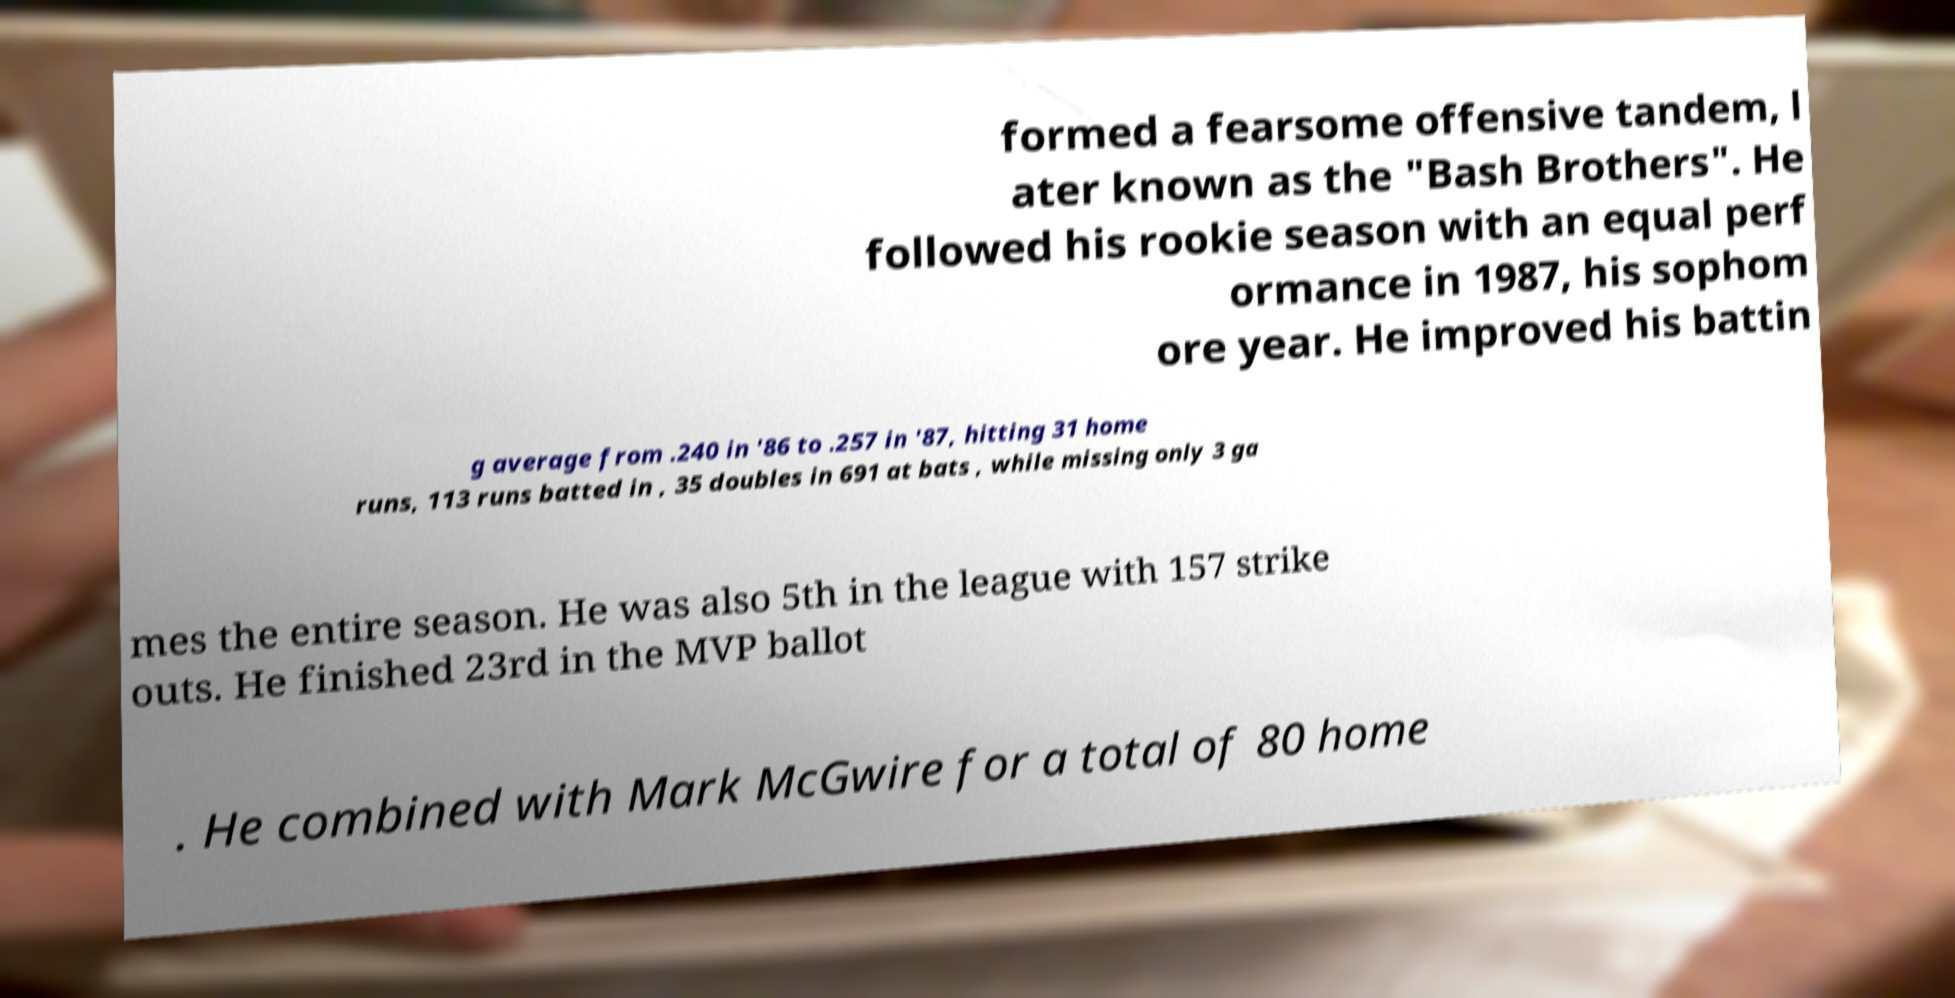Can you accurately transcribe the text from the provided image for me? formed a fearsome offensive tandem, l ater known as the "Bash Brothers". He followed his rookie season with an equal perf ormance in 1987, his sophom ore year. He improved his battin g average from .240 in '86 to .257 in '87, hitting 31 home runs, 113 runs batted in , 35 doubles in 691 at bats , while missing only 3 ga mes the entire season. He was also 5th in the league with 157 strike outs. He finished 23rd in the MVP ballot . He combined with Mark McGwire for a total of 80 home 